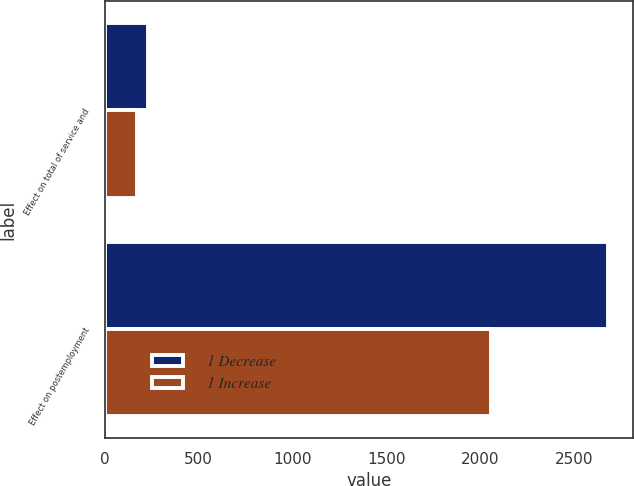Convert chart to OTSL. <chart><loc_0><loc_0><loc_500><loc_500><stacked_bar_chart><ecel><fcel>Effect on total of service and<fcel>Effect on postemployment<nl><fcel>1 Decrease<fcel>229<fcel>2680<nl><fcel>1 Increase<fcel>169<fcel>2058<nl></chart> 